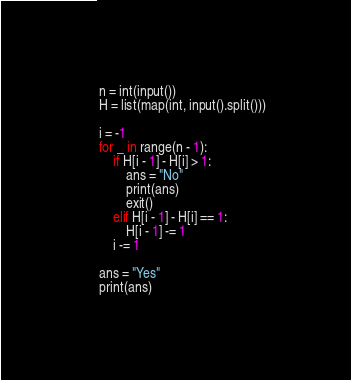Convert code to text. <code><loc_0><loc_0><loc_500><loc_500><_Python_>n = int(input())
H = list(map(int, input().split()))

i = -1
for _ in range(n - 1):
    if H[i - 1] - H[i] > 1:
        ans = "No"
        print(ans)
        exit()
    elif H[i - 1] - H[i] == 1:
        H[i - 1] -= 1
    i -= 1

ans = "Yes"
print(ans)
</code> 